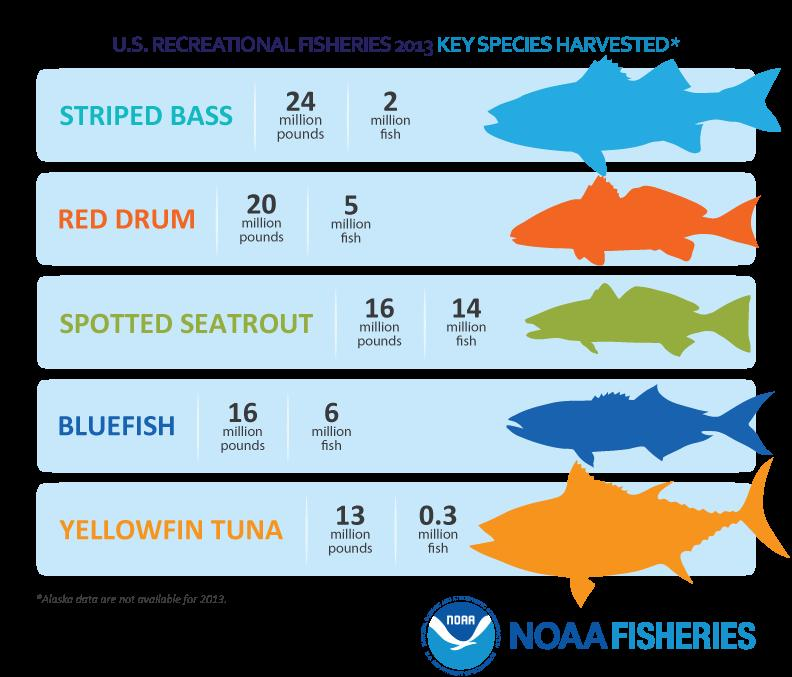Identify some key points in this picture. There are approximately 5 million Red drums in existence. There are approximately 0.3 million Yellowfin Tuna listed. There are approximately 2 million Striped Bass listed. There are approximately 6 million blue fish in existence. There are 5 species listed. 